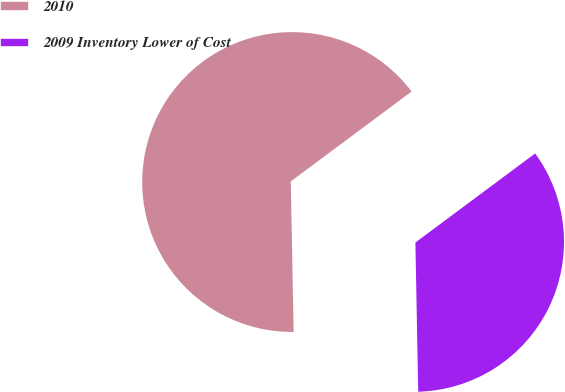<chart> <loc_0><loc_0><loc_500><loc_500><pie_chart><fcel>2010<fcel>2009 Inventory Lower of Cost<nl><fcel>65.12%<fcel>34.88%<nl></chart> 